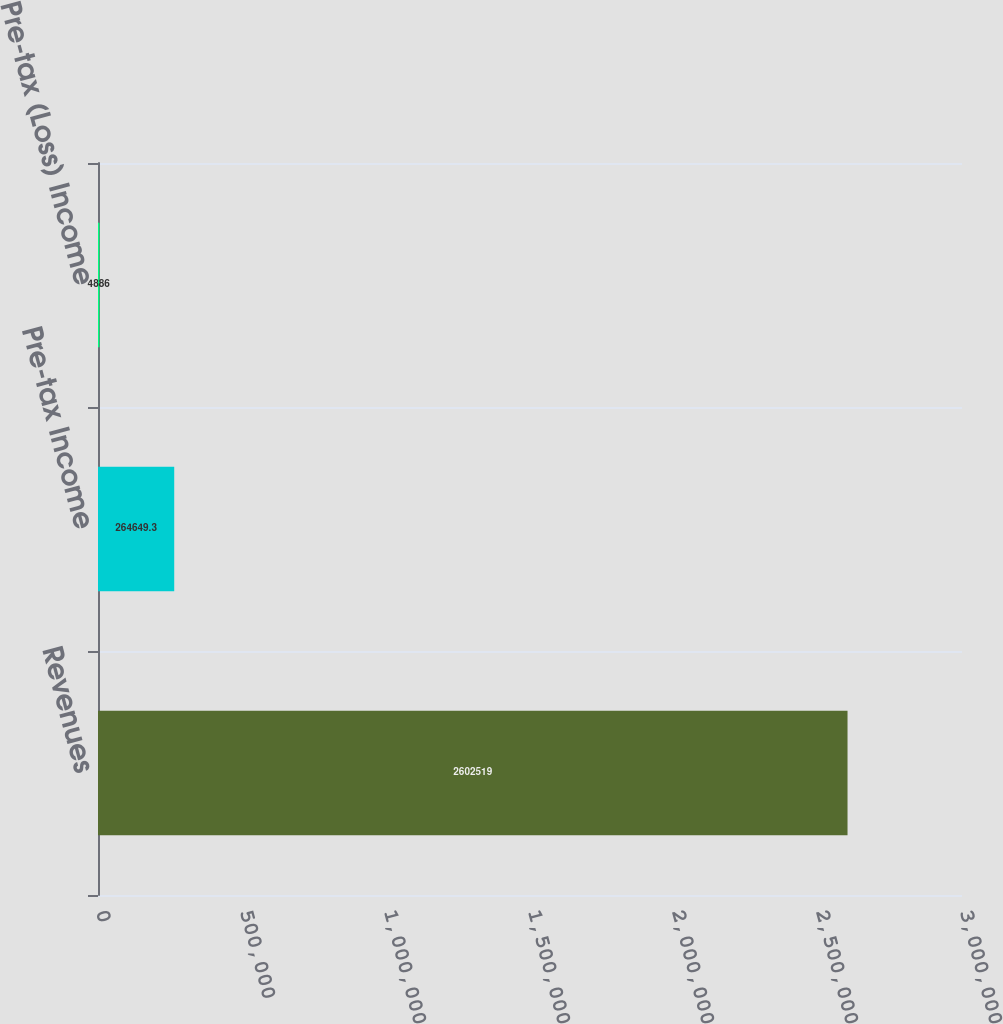Convert chart to OTSL. <chart><loc_0><loc_0><loc_500><loc_500><bar_chart><fcel>Revenues<fcel>Pre-tax Income<fcel>Pre-tax (Loss) Income<nl><fcel>2.60252e+06<fcel>264649<fcel>4886<nl></chart> 